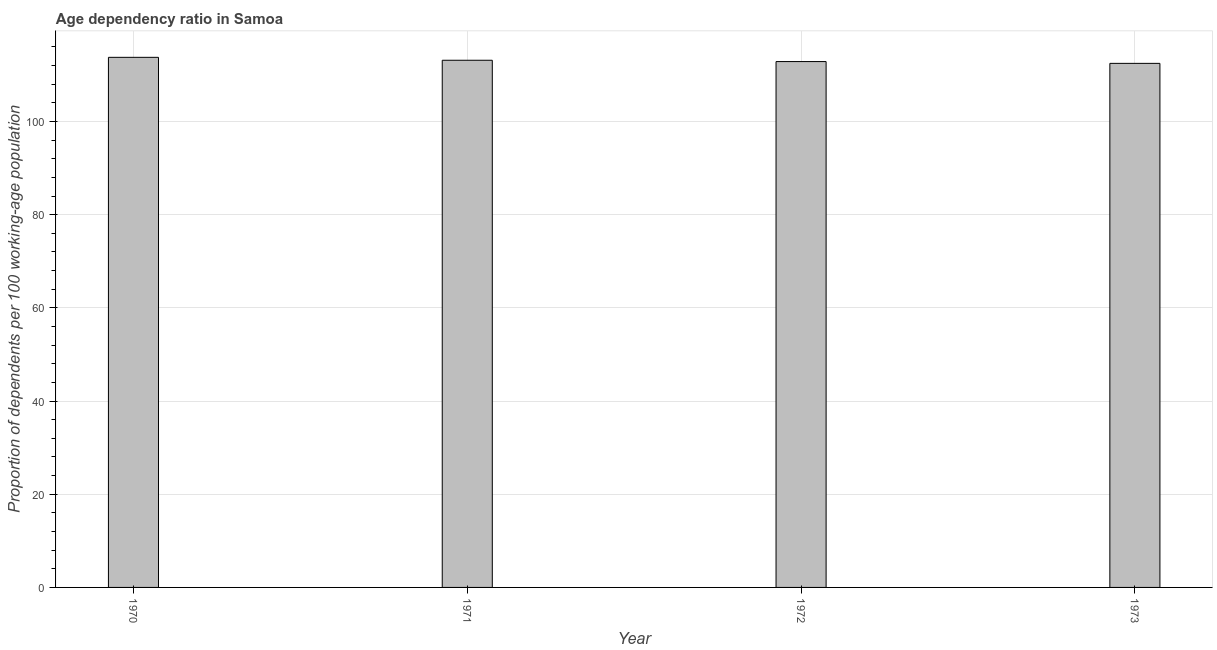Does the graph contain grids?
Your answer should be compact. Yes. What is the title of the graph?
Keep it short and to the point. Age dependency ratio in Samoa. What is the label or title of the X-axis?
Offer a terse response. Year. What is the label or title of the Y-axis?
Provide a short and direct response. Proportion of dependents per 100 working-age population. What is the age dependency ratio in 1972?
Give a very brief answer. 112.87. Across all years, what is the maximum age dependency ratio?
Your response must be concise. 113.78. Across all years, what is the minimum age dependency ratio?
Give a very brief answer. 112.48. What is the sum of the age dependency ratio?
Provide a short and direct response. 452.28. What is the difference between the age dependency ratio in 1970 and 1971?
Your response must be concise. 0.63. What is the average age dependency ratio per year?
Keep it short and to the point. 113.07. What is the median age dependency ratio?
Make the answer very short. 113.01. Do a majority of the years between 1973 and 1970 (inclusive) have age dependency ratio greater than 24 ?
Offer a terse response. Yes. What is the ratio of the age dependency ratio in 1970 to that in 1971?
Make the answer very short. 1.01. What is the difference between the highest and the second highest age dependency ratio?
Provide a short and direct response. 0.63. How many bars are there?
Provide a short and direct response. 4. Are all the bars in the graph horizontal?
Provide a succinct answer. No. How many years are there in the graph?
Offer a very short reply. 4. Are the values on the major ticks of Y-axis written in scientific E-notation?
Your response must be concise. No. What is the Proportion of dependents per 100 working-age population of 1970?
Your answer should be compact. 113.78. What is the Proportion of dependents per 100 working-age population of 1971?
Your response must be concise. 113.15. What is the Proportion of dependents per 100 working-age population of 1972?
Keep it short and to the point. 112.87. What is the Proportion of dependents per 100 working-age population in 1973?
Your answer should be very brief. 112.48. What is the difference between the Proportion of dependents per 100 working-age population in 1970 and 1971?
Offer a very short reply. 0.63. What is the difference between the Proportion of dependents per 100 working-age population in 1970 and 1972?
Your answer should be very brief. 0.91. What is the difference between the Proportion of dependents per 100 working-age population in 1970 and 1973?
Keep it short and to the point. 1.3. What is the difference between the Proportion of dependents per 100 working-age population in 1971 and 1972?
Offer a terse response. 0.28. What is the difference between the Proportion of dependents per 100 working-age population in 1971 and 1973?
Provide a short and direct response. 0.67. What is the difference between the Proportion of dependents per 100 working-age population in 1972 and 1973?
Provide a succinct answer. 0.39. What is the ratio of the Proportion of dependents per 100 working-age population in 1970 to that in 1973?
Provide a succinct answer. 1.01. 